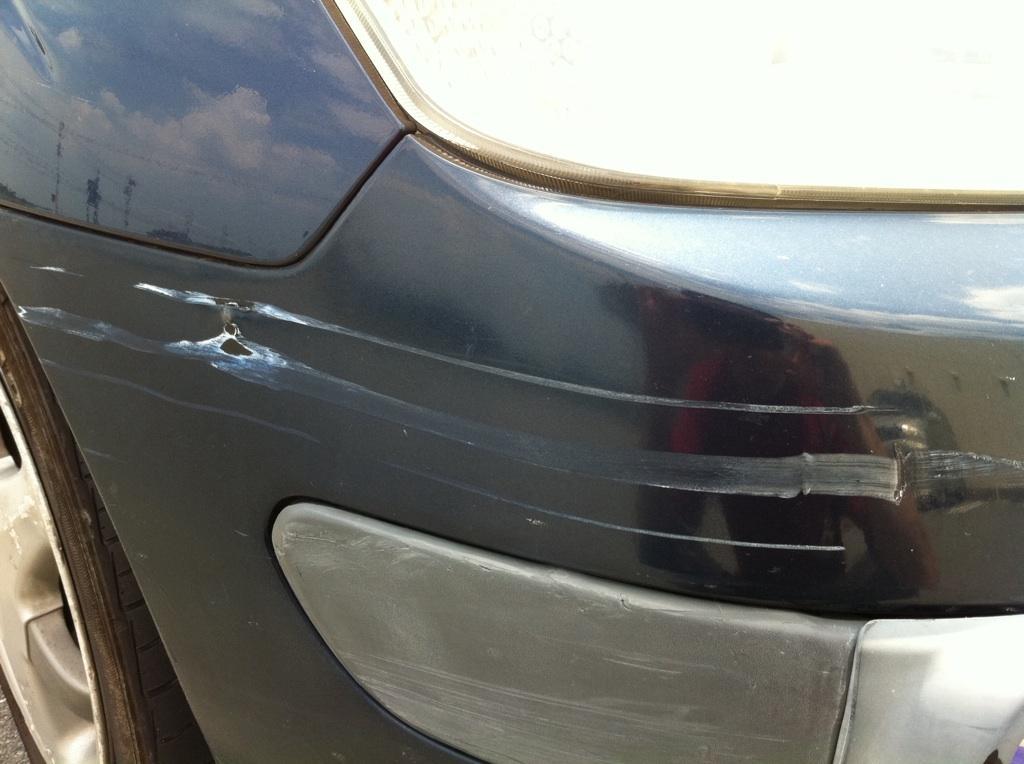Describe this image in one or two sentences. As we can see in the image there is a black color car, Tyre and head light. 